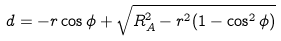<formula> <loc_0><loc_0><loc_500><loc_500>d = - r \cos \phi + \sqrt { R _ { A } ^ { 2 } - r ^ { 2 } ( 1 - \cos ^ { 2 } \phi ) }</formula> 